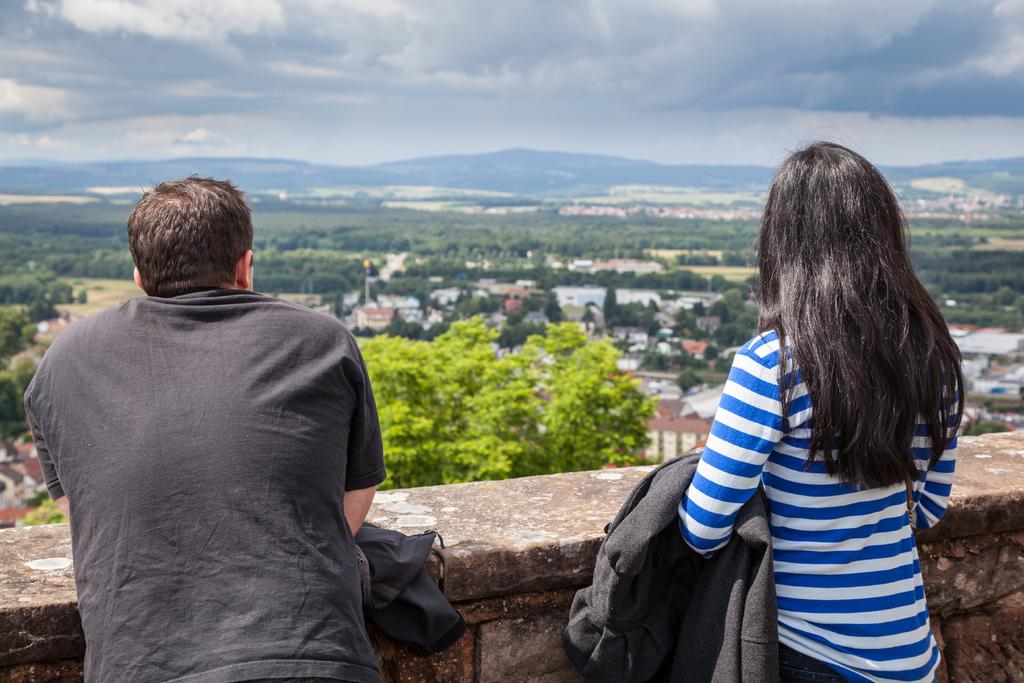Who are the people in the image? There is a man and a woman in the image. What are the man and woman doing in the image? The man and woman are standing at a wall. What type of clothing can be seen in the image? There are jackets visible in the image. What can be seen in the background of the image? There are trees, buildings, hills, and clouds in the sky in the background of the image. What type of flowers can be seen growing near the man and woman in the image? There are no flowers visible in the image. Can you tell me how many grandmothers are present in the image? There is no mention of a grandmother in the image. 